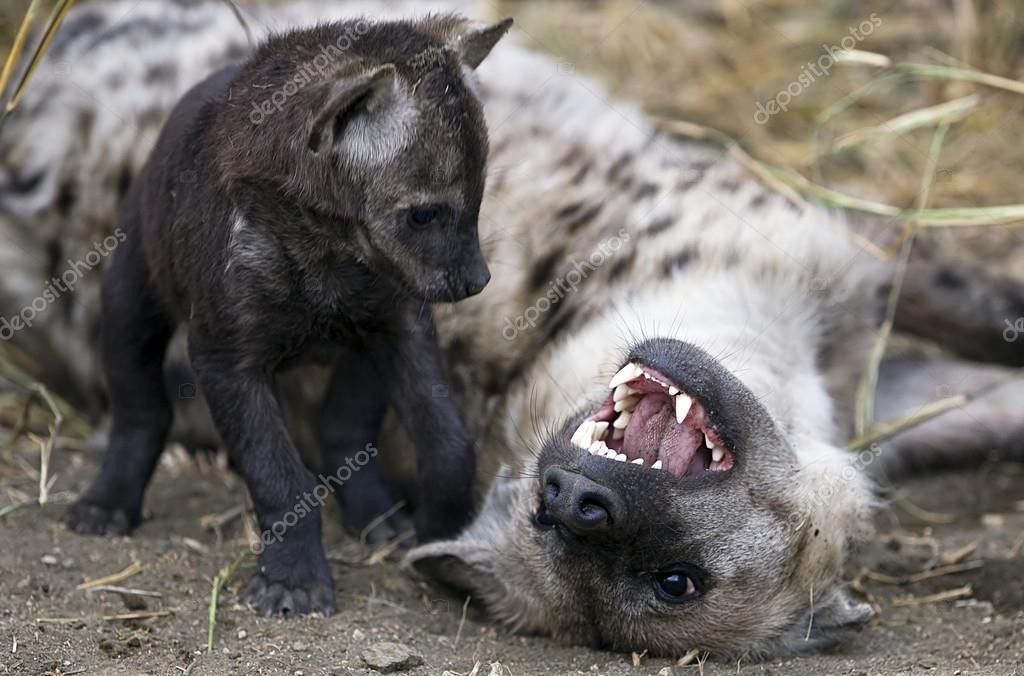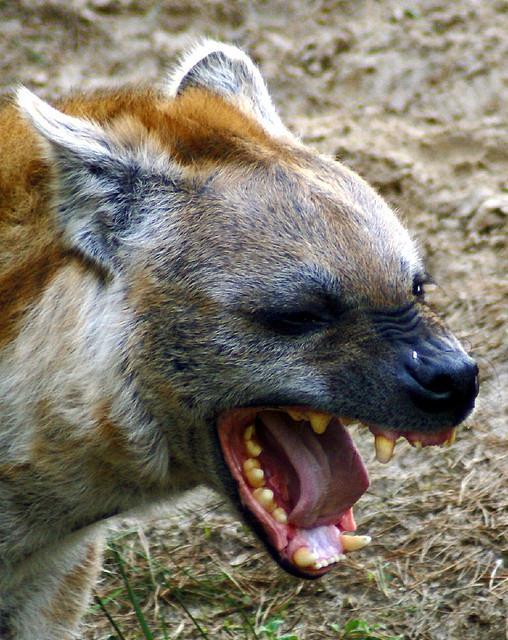The first image is the image on the left, the second image is the image on the right. Considering the images on both sides, is "At least one image shows an upright young hyena with something that is not part of a prey animal held in its mouth." valid? Answer yes or no. No. The first image is the image on the left, the second image is the image on the right. Evaluate the accuracy of this statement regarding the images: "The left image contains two hyenas.". Is it true? Answer yes or no. Yes. 